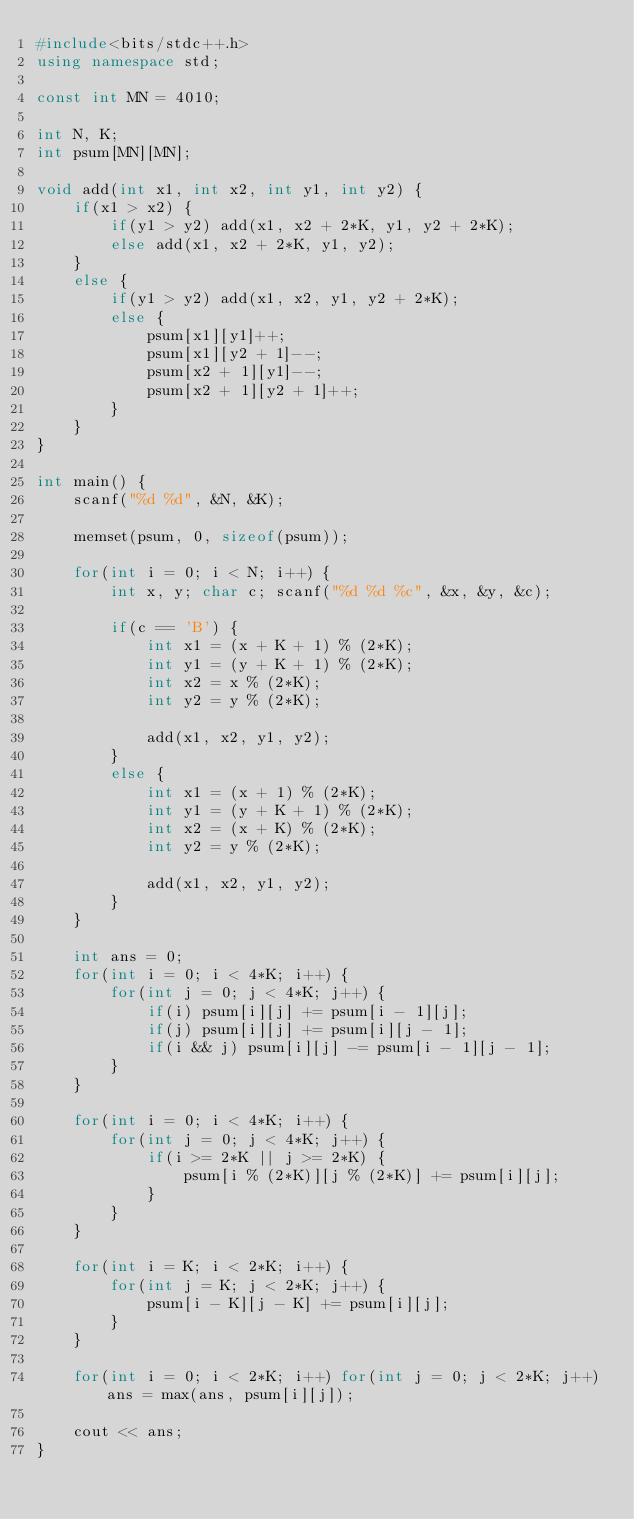Convert code to text. <code><loc_0><loc_0><loc_500><loc_500><_C++_>#include<bits/stdc++.h>
using namespace std;

const int MN = 4010;

int N, K;
int psum[MN][MN];

void add(int x1, int x2, int y1, int y2) {
    if(x1 > x2) {
        if(y1 > y2) add(x1, x2 + 2*K, y1, y2 + 2*K);
        else add(x1, x2 + 2*K, y1, y2);
    }
    else {
        if(y1 > y2) add(x1, x2, y1, y2 + 2*K);
        else {
            psum[x1][y1]++;
            psum[x1][y2 + 1]--;
            psum[x2 + 1][y1]--;
            psum[x2 + 1][y2 + 1]++;
        }
    }
}

int main() {
    scanf("%d %d", &N, &K);

    memset(psum, 0, sizeof(psum));

    for(int i = 0; i < N; i++) {
        int x, y; char c; scanf("%d %d %c", &x, &y, &c);

        if(c == 'B') {
            int x1 = (x + K + 1) % (2*K);
            int y1 = (y + K + 1) % (2*K);
            int x2 = x % (2*K);
            int y2 = y % (2*K);

            add(x1, x2, y1, y2);
        }
        else {
            int x1 = (x + 1) % (2*K);
            int y1 = (y + K + 1) % (2*K);
            int x2 = (x + K) % (2*K);
            int y2 = y % (2*K);

            add(x1, x2, y1, y2);
        }
    }

    int ans = 0;
    for(int i = 0; i < 4*K; i++) {
        for(int j = 0; j < 4*K; j++) {
            if(i) psum[i][j] += psum[i - 1][j];
            if(j) psum[i][j] += psum[i][j - 1];
            if(i && j) psum[i][j] -= psum[i - 1][j - 1];
        }
    }

    for(int i = 0; i < 4*K; i++) {
        for(int j = 0; j < 4*K; j++) {
            if(i >= 2*K || j >= 2*K) {
                psum[i % (2*K)][j % (2*K)] += psum[i][j];
            }
        }
    }

    for(int i = K; i < 2*K; i++) {
        for(int j = K; j < 2*K; j++) {
            psum[i - K][j - K] += psum[i][j];
        }
    }

    for(int i = 0; i < 2*K; i++) for(int j = 0; j < 2*K; j++) ans = max(ans, psum[i][j]);

    cout << ans;
}
</code> 